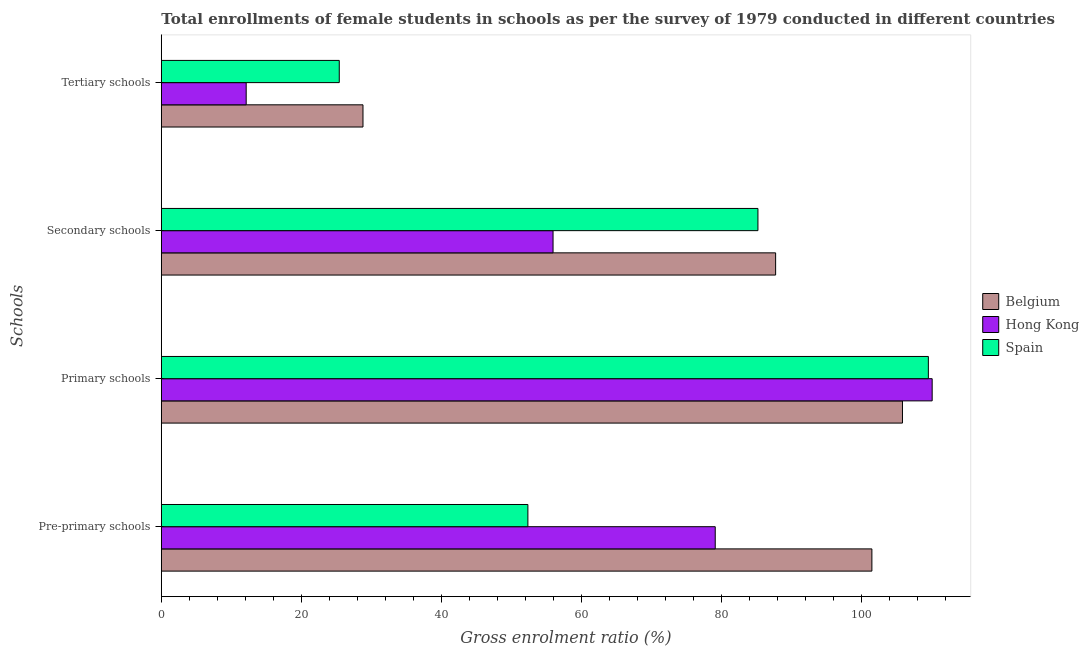How many different coloured bars are there?
Offer a terse response. 3. How many groups of bars are there?
Make the answer very short. 4. How many bars are there on the 2nd tick from the top?
Offer a very short reply. 3. How many bars are there on the 1st tick from the bottom?
Provide a succinct answer. 3. What is the label of the 4th group of bars from the top?
Provide a succinct answer. Pre-primary schools. What is the gross enrolment ratio(female) in tertiary schools in Belgium?
Your answer should be compact. 28.81. Across all countries, what is the maximum gross enrolment ratio(female) in pre-primary schools?
Give a very brief answer. 101.53. Across all countries, what is the minimum gross enrolment ratio(female) in pre-primary schools?
Your answer should be very brief. 52.38. What is the total gross enrolment ratio(female) in pre-primary schools in the graph?
Keep it short and to the point. 233.04. What is the difference between the gross enrolment ratio(female) in pre-primary schools in Spain and that in Hong Kong?
Ensure brevity in your answer.  -26.77. What is the difference between the gross enrolment ratio(female) in primary schools in Hong Kong and the gross enrolment ratio(female) in tertiary schools in Spain?
Your answer should be compact. 84.71. What is the average gross enrolment ratio(female) in pre-primary schools per country?
Offer a terse response. 77.68. What is the difference between the gross enrolment ratio(female) in pre-primary schools and gross enrolment ratio(female) in secondary schools in Belgium?
Your answer should be compact. 13.75. In how many countries, is the gross enrolment ratio(female) in secondary schools greater than 8 %?
Offer a very short reply. 3. What is the ratio of the gross enrolment ratio(female) in secondary schools in Belgium to that in Hong Kong?
Your answer should be very brief. 1.57. What is the difference between the highest and the second highest gross enrolment ratio(female) in secondary schools?
Make the answer very short. 2.53. What is the difference between the highest and the lowest gross enrolment ratio(female) in tertiary schools?
Provide a succinct answer. 16.69. In how many countries, is the gross enrolment ratio(female) in pre-primary schools greater than the average gross enrolment ratio(female) in pre-primary schools taken over all countries?
Your response must be concise. 2. Is it the case that in every country, the sum of the gross enrolment ratio(female) in pre-primary schools and gross enrolment ratio(female) in tertiary schools is greater than the sum of gross enrolment ratio(female) in primary schools and gross enrolment ratio(female) in secondary schools?
Provide a short and direct response. No. What does the 1st bar from the bottom in Primary schools represents?
Your response must be concise. Belgium. Is it the case that in every country, the sum of the gross enrolment ratio(female) in pre-primary schools and gross enrolment ratio(female) in primary schools is greater than the gross enrolment ratio(female) in secondary schools?
Your answer should be compact. Yes. Are all the bars in the graph horizontal?
Ensure brevity in your answer.  Yes. What is the difference between two consecutive major ticks on the X-axis?
Keep it short and to the point. 20. Are the values on the major ticks of X-axis written in scientific E-notation?
Offer a very short reply. No. Does the graph contain grids?
Your answer should be very brief. No. Where does the legend appear in the graph?
Your response must be concise. Center right. How many legend labels are there?
Offer a terse response. 3. What is the title of the graph?
Provide a succinct answer. Total enrollments of female students in schools as per the survey of 1979 conducted in different countries. What is the label or title of the Y-axis?
Your answer should be very brief. Schools. What is the Gross enrolment ratio (%) in Belgium in Pre-primary schools?
Keep it short and to the point. 101.53. What is the Gross enrolment ratio (%) in Hong Kong in Pre-primary schools?
Keep it short and to the point. 79.14. What is the Gross enrolment ratio (%) of Spain in Pre-primary schools?
Offer a very short reply. 52.38. What is the Gross enrolment ratio (%) in Belgium in Primary schools?
Offer a very short reply. 105.89. What is the Gross enrolment ratio (%) of Hong Kong in Primary schools?
Offer a very short reply. 110.14. What is the Gross enrolment ratio (%) in Spain in Primary schools?
Provide a succinct answer. 109.59. What is the Gross enrolment ratio (%) of Belgium in Secondary schools?
Your answer should be compact. 87.77. What is the Gross enrolment ratio (%) of Hong Kong in Secondary schools?
Offer a very short reply. 55.97. What is the Gross enrolment ratio (%) of Spain in Secondary schools?
Provide a succinct answer. 85.24. What is the Gross enrolment ratio (%) of Belgium in Tertiary schools?
Offer a terse response. 28.81. What is the Gross enrolment ratio (%) in Hong Kong in Tertiary schools?
Give a very brief answer. 12.13. What is the Gross enrolment ratio (%) of Spain in Tertiary schools?
Give a very brief answer. 25.43. Across all Schools, what is the maximum Gross enrolment ratio (%) in Belgium?
Your response must be concise. 105.89. Across all Schools, what is the maximum Gross enrolment ratio (%) in Hong Kong?
Provide a succinct answer. 110.14. Across all Schools, what is the maximum Gross enrolment ratio (%) of Spain?
Give a very brief answer. 109.59. Across all Schools, what is the minimum Gross enrolment ratio (%) in Belgium?
Offer a very short reply. 28.81. Across all Schools, what is the minimum Gross enrolment ratio (%) of Hong Kong?
Your response must be concise. 12.13. Across all Schools, what is the minimum Gross enrolment ratio (%) in Spain?
Keep it short and to the point. 25.43. What is the total Gross enrolment ratio (%) of Belgium in the graph?
Your response must be concise. 324.01. What is the total Gross enrolment ratio (%) in Hong Kong in the graph?
Offer a terse response. 257.38. What is the total Gross enrolment ratio (%) of Spain in the graph?
Offer a terse response. 272.64. What is the difference between the Gross enrolment ratio (%) in Belgium in Pre-primary schools and that in Primary schools?
Offer a terse response. -4.37. What is the difference between the Gross enrolment ratio (%) of Hong Kong in Pre-primary schools and that in Primary schools?
Provide a short and direct response. -30.99. What is the difference between the Gross enrolment ratio (%) of Spain in Pre-primary schools and that in Primary schools?
Ensure brevity in your answer.  -57.22. What is the difference between the Gross enrolment ratio (%) of Belgium in Pre-primary schools and that in Secondary schools?
Offer a very short reply. 13.75. What is the difference between the Gross enrolment ratio (%) in Hong Kong in Pre-primary schools and that in Secondary schools?
Your answer should be very brief. 23.17. What is the difference between the Gross enrolment ratio (%) of Spain in Pre-primary schools and that in Secondary schools?
Your answer should be very brief. -32.87. What is the difference between the Gross enrolment ratio (%) of Belgium in Pre-primary schools and that in Tertiary schools?
Your response must be concise. 72.71. What is the difference between the Gross enrolment ratio (%) in Hong Kong in Pre-primary schools and that in Tertiary schools?
Give a very brief answer. 67.02. What is the difference between the Gross enrolment ratio (%) of Spain in Pre-primary schools and that in Tertiary schools?
Provide a short and direct response. 26.95. What is the difference between the Gross enrolment ratio (%) in Belgium in Primary schools and that in Secondary schools?
Your answer should be compact. 18.12. What is the difference between the Gross enrolment ratio (%) in Hong Kong in Primary schools and that in Secondary schools?
Make the answer very short. 54.17. What is the difference between the Gross enrolment ratio (%) in Spain in Primary schools and that in Secondary schools?
Give a very brief answer. 24.35. What is the difference between the Gross enrolment ratio (%) of Belgium in Primary schools and that in Tertiary schools?
Your answer should be very brief. 77.08. What is the difference between the Gross enrolment ratio (%) of Hong Kong in Primary schools and that in Tertiary schools?
Your answer should be compact. 98.01. What is the difference between the Gross enrolment ratio (%) of Spain in Primary schools and that in Tertiary schools?
Make the answer very short. 84.17. What is the difference between the Gross enrolment ratio (%) of Belgium in Secondary schools and that in Tertiary schools?
Your answer should be compact. 58.96. What is the difference between the Gross enrolment ratio (%) of Hong Kong in Secondary schools and that in Tertiary schools?
Your response must be concise. 43.84. What is the difference between the Gross enrolment ratio (%) in Spain in Secondary schools and that in Tertiary schools?
Offer a very short reply. 59.82. What is the difference between the Gross enrolment ratio (%) in Belgium in Pre-primary schools and the Gross enrolment ratio (%) in Hong Kong in Primary schools?
Your answer should be compact. -8.61. What is the difference between the Gross enrolment ratio (%) of Belgium in Pre-primary schools and the Gross enrolment ratio (%) of Spain in Primary schools?
Your answer should be compact. -8.07. What is the difference between the Gross enrolment ratio (%) of Hong Kong in Pre-primary schools and the Gross enrolment ratio (%) of Spain in Primary schools?
Make the answer very short. -30.45. What is the difference between the Gross enrolment ratio (%) of Belgium in Pre-primary schools and the Gross enrolment ratio (%) of Hong Kong in Secondary schools?
Offer a very short reply. 45.55. What is the difference between the Gross enrolment ratio (%) of Belgium in Pre-primary schools and the Gross enrolment ratio (%) of Spain in Secondary schools?
Your answer should be very brief. 16.28. What is the difference between the Gross enrolment ratio (%) in Hong Kong in Pre-primary schools and the Gross enrolment ratio (%) in Spain in Secondary schools?
Keep it short and to the point. -6.1. What is the difference between the Gross enrolment ratio (%) of Belgium in Pre-primary schools and the Gross enrolment ratio (%) of Hong Kong in Tertiary schools?
Offer a very short reply. 89.4. What is the difference between the Gross enrolment ratio (%) in Belgium in Pre-primary schools and the Gross enrolment ratio (%) in Spain in Tertiary schools?
Your response must be concise. 76.1. What is the difference between the Gross enrolment ratio (%) of Hong Kong in Pre-primary schools and the Gross enrolment ratio (%) of Spain in Tertiary schools?
Provide a short and direct response. 53.72. What is the difference between the Gross enrolment ratio (%) of Belgium in Primary schools and the Gross enrolment ratio (%) of Hong Kong in Secondary schools?
Make the answer very short. 49.92. What is the difference between the Gross enrolment ratio (%) in Belgium in Primary schools and the Gross enrolment ratio (%) in Spain in Secondary schools?
Keep it short and to the point. 20.65. What is the difference between the Gross enrolment ratio (%) of Hong Kong in Primary schools and the Gross enrolment ratio (%) of Spain in Secondary schools?
Keep it short and to the point. 24.89. What is the difference between the Gross enrolment ratio (%) in Belgium in Primary schools and the Gross enrolment ratio (%) in Hong Kong in Tertiary schools?
Give a very brief answer. 93.77. What is the difference between the Gross enrolment ratio (%) in Belgium in Primary schools and the Gross enrolment ratio (%) in Spain in Tertiary schools?
Ensure brevity in your answer.  80.47. What is the difference between the Gross enrolment ratio (%) in Hong Kong in Primary schools and the Gross enrolment ratio (%) in Spain in Tertiary schools?
Your response must be concise. 84.71. What is the difference between the Gross enrolment ratio (%) of Belgium in Secondary schools and the Gross enrolment ratio (%) of Hong Kong in Tertiary schools?
Your answer should be very brief. 75.64. What is the difference between the Gross enrolment ratio (%) of Belgium in Secondary schools and the Gross enrolment ratio (%) of Spain in Tertiary schools?
Provide a short and direct response. 62.35. What is the difference between the Gross enrolment ratio (%) of Hong Kong in Secondary schools and the Gross enrolment ratio (%) of Spain in Tertiary schools?
Give a very brief answer. 30.54. What is the average Gross enrolment ratio (%) of Belgium per Schools?
Your response must be concise. 81. What is the average Gross enrolment ratio (%) of Hong Kong per Schools?
Offer a very short reply. 64.34. What is the average Gross enrolment ratio (%) of Spain per Schools?
Keep it short and to the point. 68.16. What is the difference between the Gross enrolment ratio (%) of Belgium and Gross enrolment ratio (%) of Hong Kong in Pre-primary schools?
Offer a terse response. 22.38. What is the difference between the Gross enrolment ratio (%) in Belgium and Gross enrolment ratio (%) in Spain in Pre-primary schools?
Make the answer very short. 49.15. What is the difference between the Gross enrolment ratio (%) in Hong Kong and Gross enrolment ratio (%) in Spain in Pre-primary schools?
Ensure brevity in your answer.  26.77. What is the difference between the Gross enrolment ratio (%) of Belgium and Gross enrolment ratio (%) of Hong Kong in Primary schools?
Keep it short and to the point. -4.24. What is the difference between the Gross enrolment ratio (%) of Belgium and Gross enrolment ratio (%) of Spain in Primary schools?
Keep it short and to the point. -3.7. What is the difference between the Gross enrolment ratio (%) of Hong Kong and Gross enrolment ratio (%) of Spain in Primary schools?
Provide a short and direct response. 0.54. What is the difference between the Gross enrolment ratio (%) in Belgium and Gross enrolment ratio (%) in Hong Kong in Secondary schools?
Keep it short and to the point. 31.8. What is the difference between the Gross enrolment ratio (%) in Belgium and Gross enrolment ratio (%) in Spain in Secondary schools?
Ensure brevity in your answer.  2.53. What is the difference between the Gross enrolment ratio (%) of Hong Kong and Gross enrolment ratio (%) of Spain in Secondary schools?
Keep it short and to the point. -29.27. What is the difference between the Gross enrolment ratio (%) of Belgium and Gross enrolment ratio (%) of Hong Kong in Tertiary schools?
Offer a terse response. 16.69. What is the difference between the Gross enrolment ratio (%) of Belgium and Gross enrolment ratio (%) of Spain in Tertiary schools?
Keep it short and to the point. 3.39. What is the difference between the Gross enrolment ratio (%) in Hong Kong and Gross enrolment ratio (%) in Spain in Tertiary schools?
Give a very brief answer. -13.3. What is the ratio of the Gross enrolment ratio (%) of Belgium in Pre-primary schools to that in Primary schools?
Your answer should be very brief. 0.96. What is the ratio of the Gross enrolment ratio (%) in Hong Kong in Pre-primary schools to that in Primary schools?
Your response must be concise. 0.72. What is the ratio of the Gross enrolment ratio (%) in Spain in Pre-primary schools to that in Primary schools?
Give a very brief answer. 0.48. What is the ratio of the Gross enrolment ratio (%) in Belgium in Pre-primary schools to that in Secondary schools?
Offer a terse response. 1.16. What is the ratio of the Gross enrolment ratio (%) in Hong Kong in Pre-primary schools to that in Secondary schools?
Provide a succinct answer. 1.41. What is the ratio of the Gross enrolment ratio (%) of Spain in Pre-primary schools to that in Secondary schools?
Provide a succinct answer. 0.61. What is the ratio of the Gross enrolment ratio (%) of Belgium in Pre-primary schools to that in Tertiary schools?
Give a very brief answer. 3.52. What is the ratio of the Gross enrolment ratio (%) in Hong Kong in Pre-primary schools to that in Tertiary schools?
Provide a succinct answer. 6.53. What is the ratio of the Gross enrolment ratio (%) in Spain in Pre-primary schools to that in Tertiary schools?
Offer a very short reply. 2.06. What is the ratio of the Gross enrolment ratio (%) in Belgium in Primary schools to that in Secondary schools?
Your answer should be compact. 1.21. What is the ratio of the Gross enrolment ratio (%) of Hong Kong in Primary schools to that in Secondary schools?
Ensure brevity in your answer.  1.97. What is the ratio of the Gross enrolment ratio (%) in Spain in Primary schools to that in Secondary schools?
Your answer should be very brief. 1.29. What is the ratio of the Gross enrolment ratio (%) in Belgium in Primary schools to that in Tertiary schools?
Give a very brief answer. 3.68. What is the ratio of the Gross enrolment ratio (%) of Hong Kong in Primary schools to that in Tertiary schools?
Offer a very short reply. 9.08. What is the ratio of the Gross enrolment ratio (%) in Spain in Primary schools to that in Tertiary schools?
Provide a short and direct response. 4.31. What is the ratio of the Gross enrolment ratio (%) of Belgium in Secondary schools to that in Tertiary schools?
Offer a very short reply. 3.05. What is the ratio of the Gross enrolment ratio (%) of Hong Kong in Secondary schools to that in Tertiary schools?
Your response must be concise. 4.62. What is the ratio of the Gross enrolment ratio (%) of Spain in Secondary schools to that in Tertiary schools?
Keep it short and to the point. 3.35. What is the difference between the highest and the second highest Gross enrolment ratio (%) of Belgium?
Offer a very short reply. 4.37. What is the difference between the highest and the second highest Gross enrolment ratio (%) of Hong Kong?
Keep it short and to the point. 30.99. What is the difference between the highest and the second highest Gross enrolment ratio (%) in Spain?
Keep it short and to the point. 24.35. What is the difference between the highest and the lowest Gross enrolment ratio (%) in Belgium?
Make the answer very short. 77.08. What is the difference between the highest and the lowest Gross enrolment ratio (%) in Hong Kong?
Keep it short and to the point. 98.01. What is the difference between the highest and the lowest Gross enrolment ratio (%) in Spain?
Offer a terse response. 84.17. 